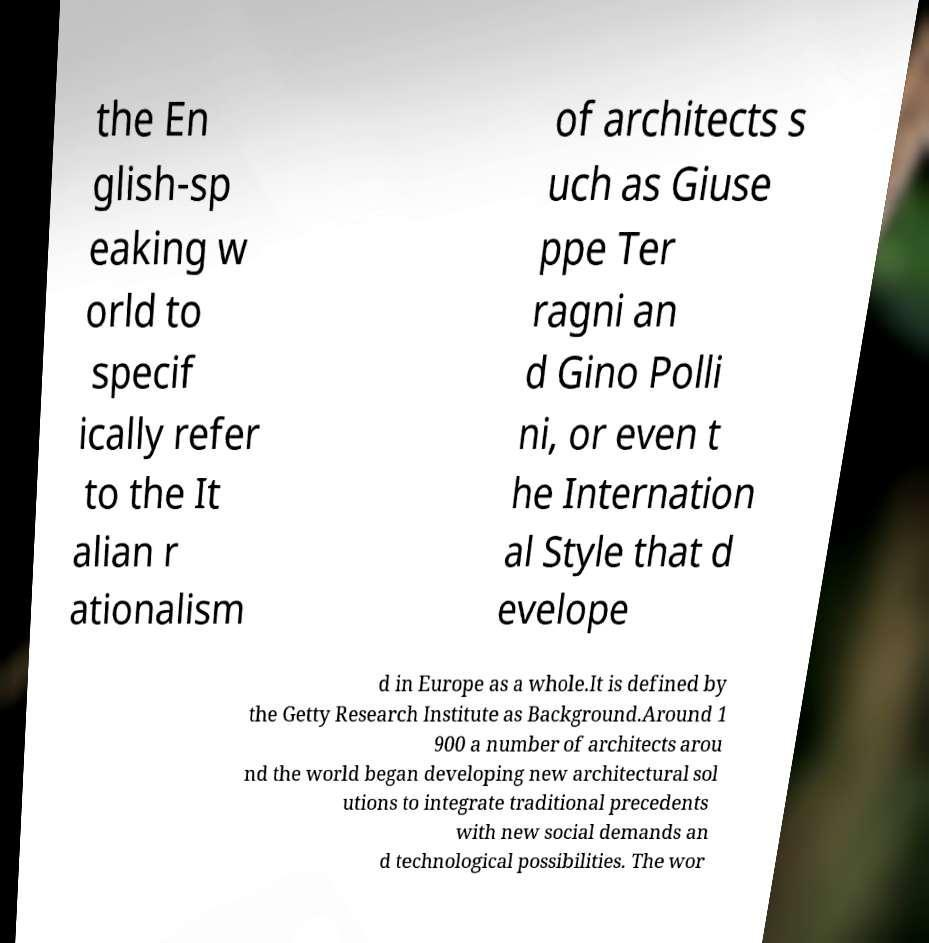Could you assist in decoding the text presented in this image and type it out clearly? the En glish-sp eaking w orld to specif ically refer to the It alian r ationalism of architects s uch as Giuse ppe Ter ragni an d Gino Polli ni, or even t he Internation al Style that d evelope d in Europe as a whole.It is defined by the Getty Research Institute as Background.Around 1 900 a number of architects arou nd the world began developing new architectural sol utions to integrate traditional precedents with new social demands an d technological possibilities. The wor 